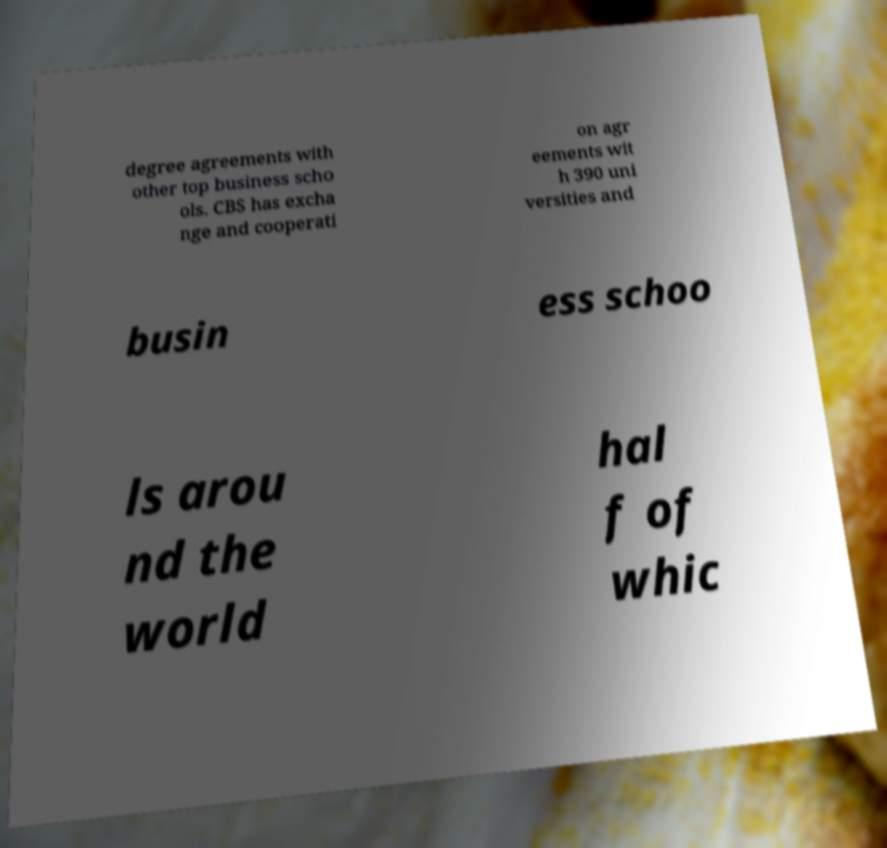There's text embedded in this image that I need extracted. Can you transcribe it verbatim? degree agreements with other top business scho ols. CBS has excha nge and cooperati on agr eements wit h 390 uni versities and busin ess schoo ls arou nd the world hal f of whic 